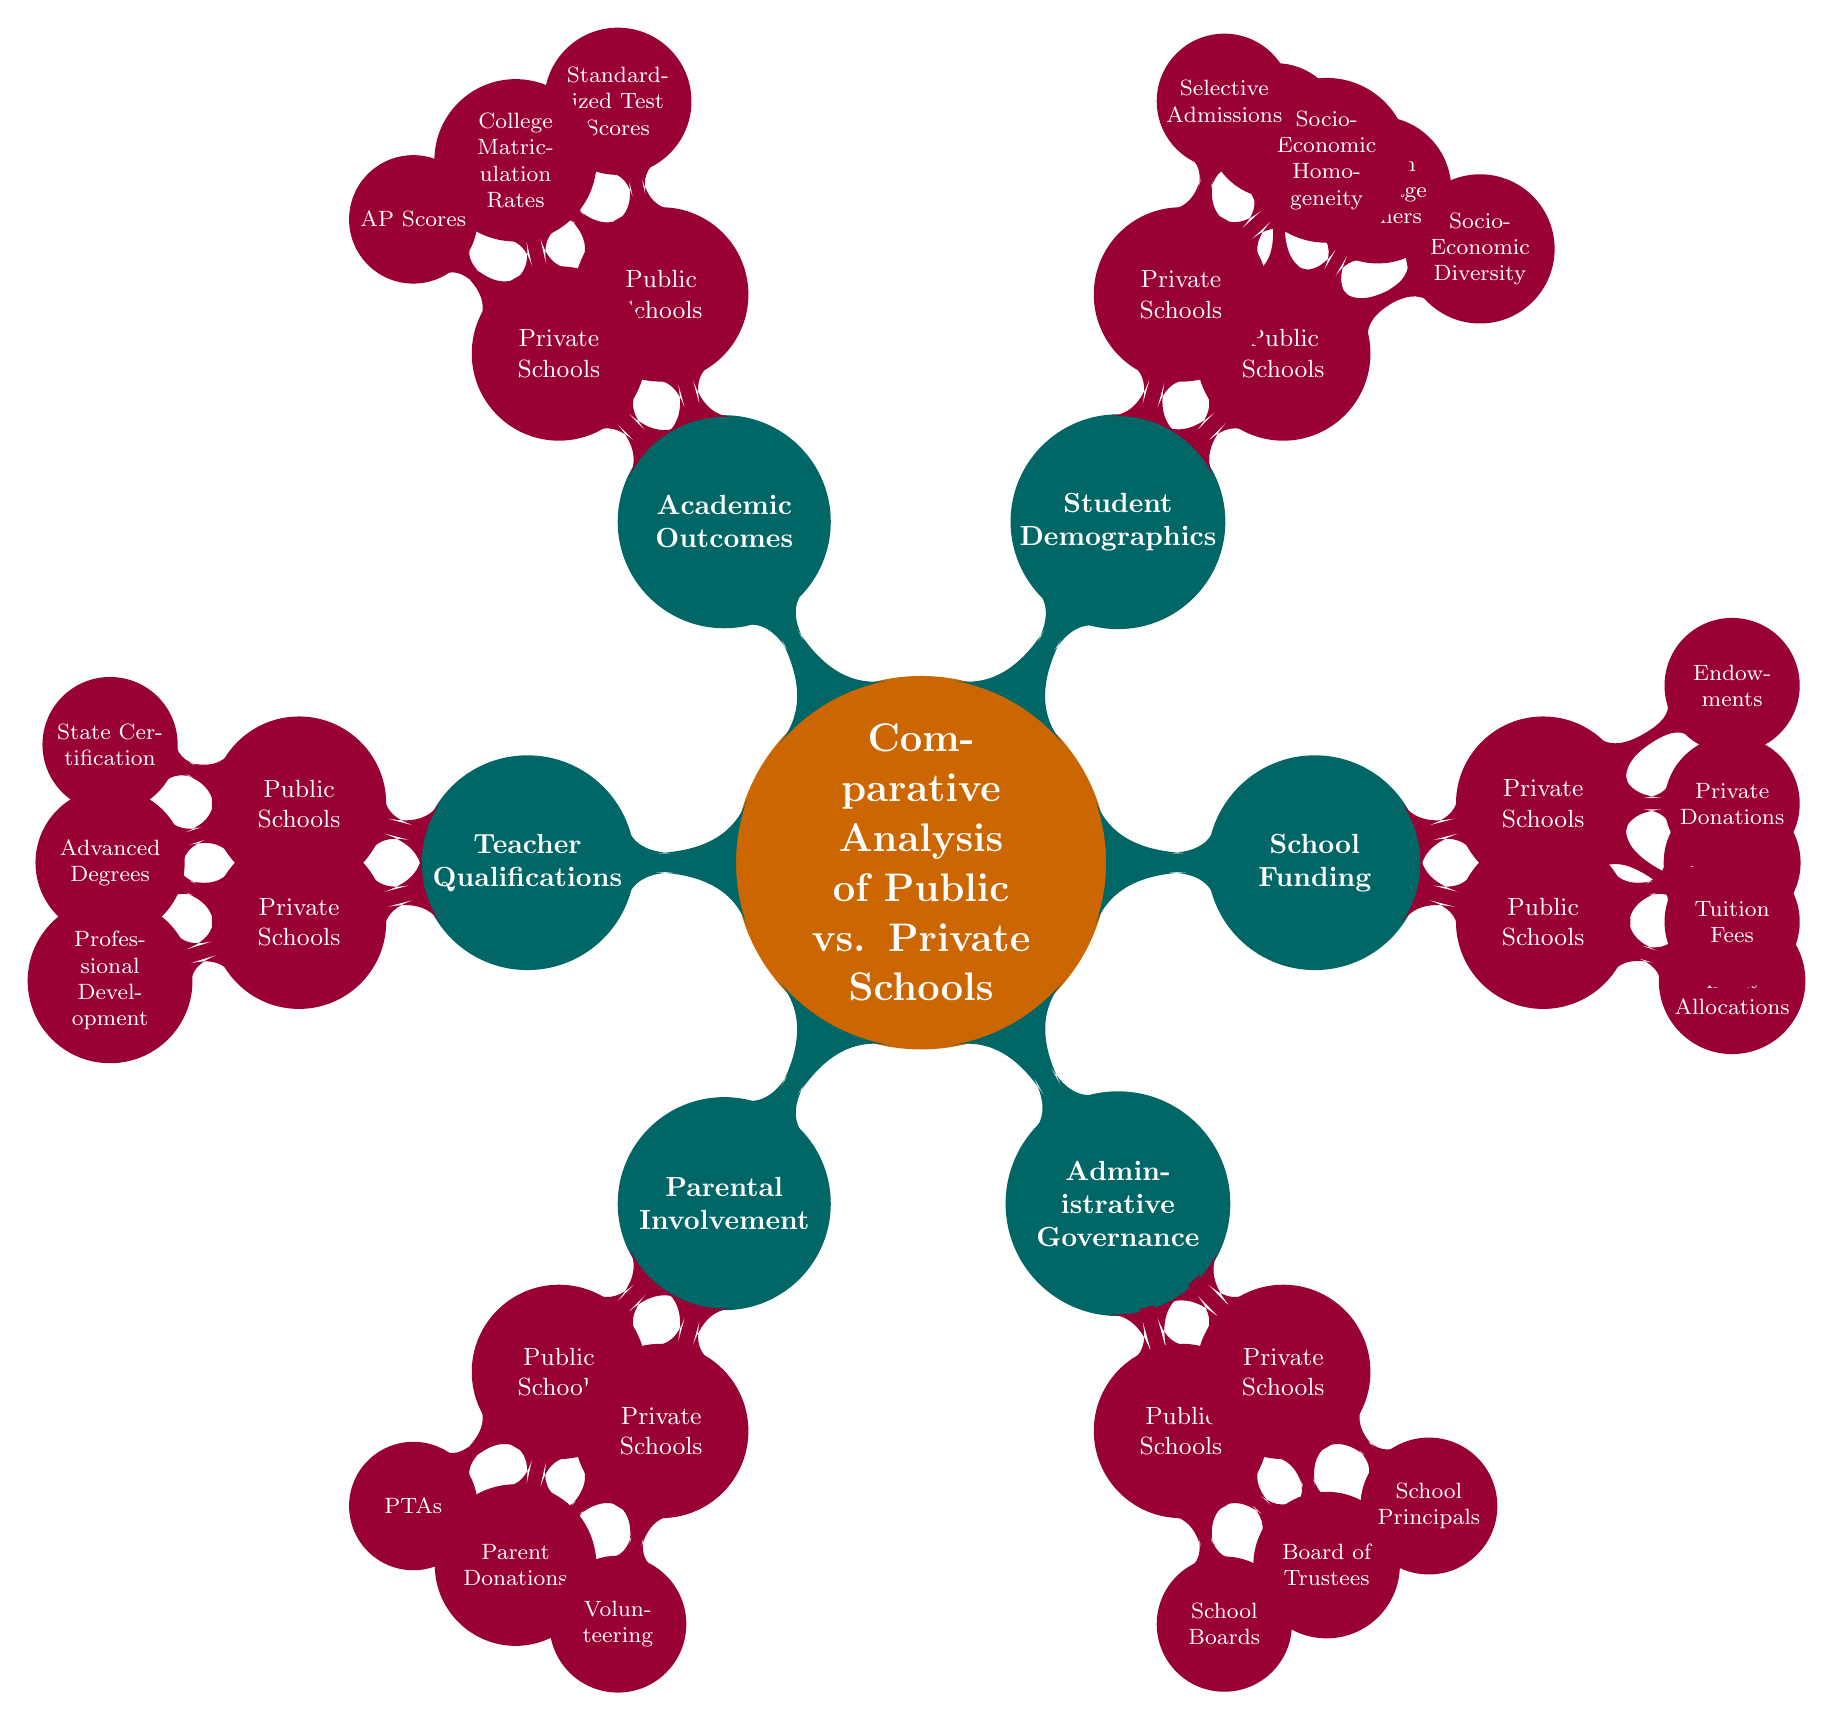What are the funding sources for public schools? The diagram shows that public schools receive funding primarily from "Government Allocations" and "Title I Funding." These pieces of information can be found under the "School Funding" node, specifically under the "Public Schools" subnode.
Answer: Government Allocations, Title I Funding How many nodes are under the "Student Demographics" category? By analyzing the "Student Demographics" node, it is clear that it contains two subnodes: "Public Schools" and "Private Schools." Each of these subnodes has their own respective subnodes too. Hence, it counts as 2 major nodes in this category.
Answer: 2 What is a characteristic of private schools concerning student demographics? The diagram indicates that private schools tend to have "Socio-Economic Homogeneity" and "Selective Admissions." This information is found under the "Student Demographics" subnode for "Private Schools."
Answer: Socio-Economic Homogeneity Which schools have "State Certification" as a qualification for teachers? Upon examining the "Teacher Qualifications" node, "State Certification" is listed under "Public Schools." This shows that this specific qualification is relevant only to teachers in public schools according to the diagram.
Answer: Public Schools What aspect of parental involvement is associated with private schools? The diagram highlights "Parent Donations" and "Volunteering in School Activities" under the "Parental Involvement" node for private schools. This indicates that private schools encourage these activities for parental involvement.
Answer: Parent Donations, Volunteering Compare the governance structure between public and private schools. The governance structure is outlined in the "Administrative Governance" category. Public schools are governed by "School Boards" and "District Superintendents," while private schools are governed by "Board of Trustees" and "School Principals." This information suggests different governance frameworks for each type.
Answer: School Boards, District Superintendents; Board of Trustees, School Principals What funding source is exclusive to private schools? Reviewing the "School Funding" category, private schools are funded through "Tuition Fees," "Private Donations," and "Endowments," while public schools have government allocations. Hence, tuition fees are an exclusive source for private schools.
Answer: Tuition Fees Which school's academic outcomes include college matriculation rates? The "Academic Outcomes" section reveals that "College Matriculation Rates" is a highlighted outcome specifically for private schools. This suggests that private schools have a distinct focus on higher education entrance compared to public schools.
Answer: Private Schools 